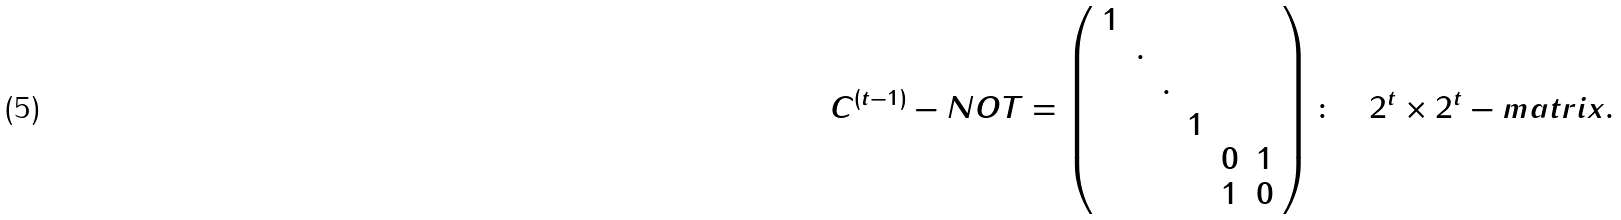Convert formula to latex. <formula><loc_0><loc_0><loc_500><loc_500>C ^ { ( t - 1 ) } - N O T = \left ( \begin{array} { c c c c c c } 1 & & & & & \\ & \cdot & & & & \\ & & \cdot & & & \\ & & & 1 & & \\ & & & & 0 & 1 \\ & & & & 1 & 0 \\ \end{array} \right ) \colon \quad 2 ^ { t } \times 2 ^ { t } - m a t r i x .</formula> 